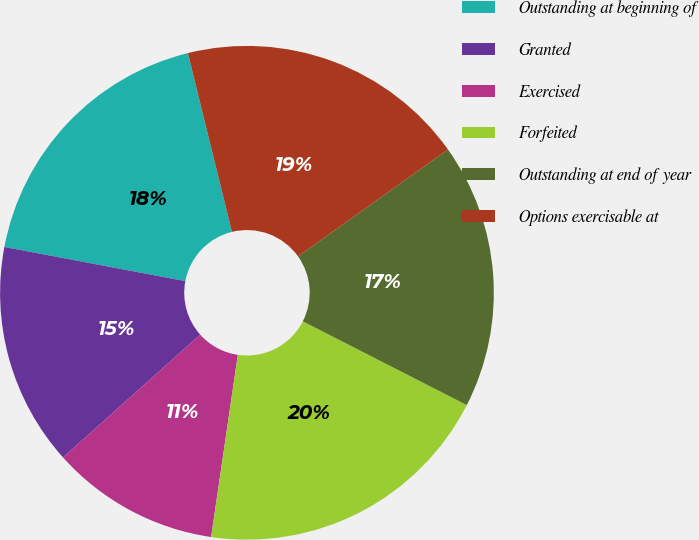Convert chart to OTSL. <chart><loc_0><loc_0><loc_500><loc_500><pie_chart><fcel>Outstanding at beginning of<fcel>Granted<fcel>Exercised<fcel>Forfeited<fcel>Outstanding at end of year<fcel>Options exercisable at<nl><fcel>18.18%<fcel>14.59%<fcel>11.06%<fcel>19.8%<fcel>17.37%<fcel>18.99%<nl></chart> 